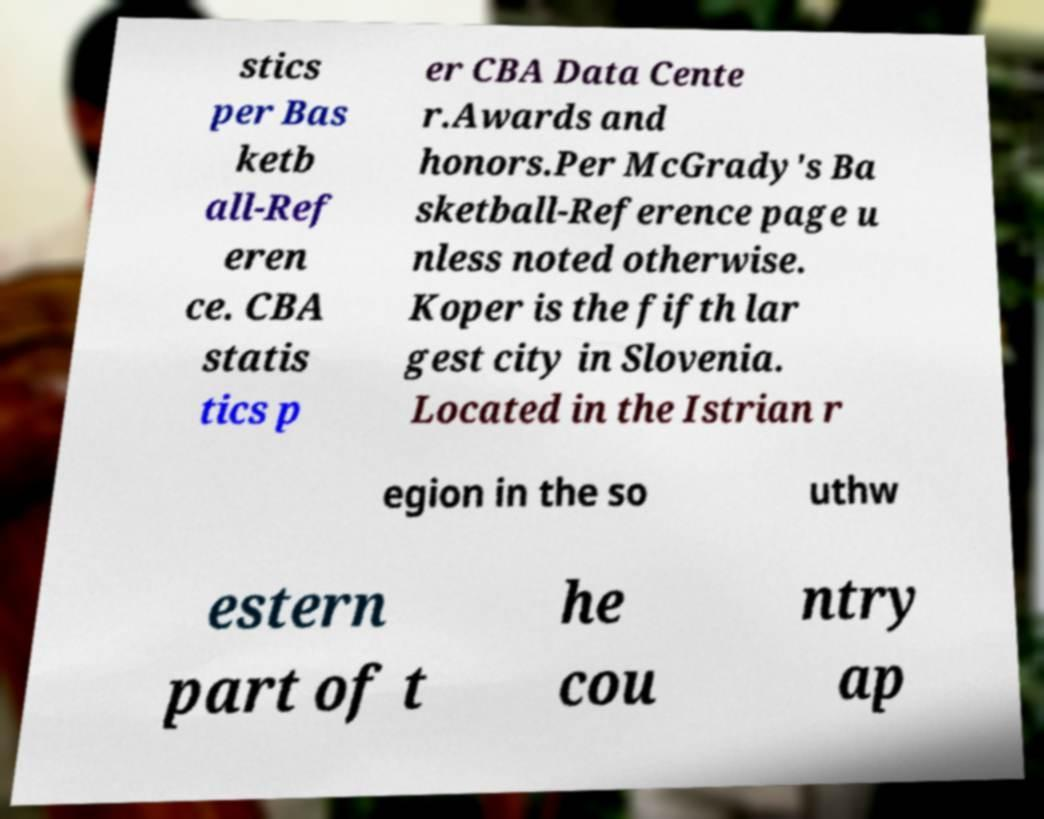There's text embedded in this image that I need extracted. Can you transcribe it verbatim? stics per Bas ketb all-Ref eren ce. CBA statis tics p er CBA Data Cente r.Awards and honors.Per McGrady's Ba sketball-Reference page u nless noted otherwise. Koper is the fifth lar gest city in Slovenia. Located in the Istrian r egion in the so uthw estern part of t he cou ntry ap 